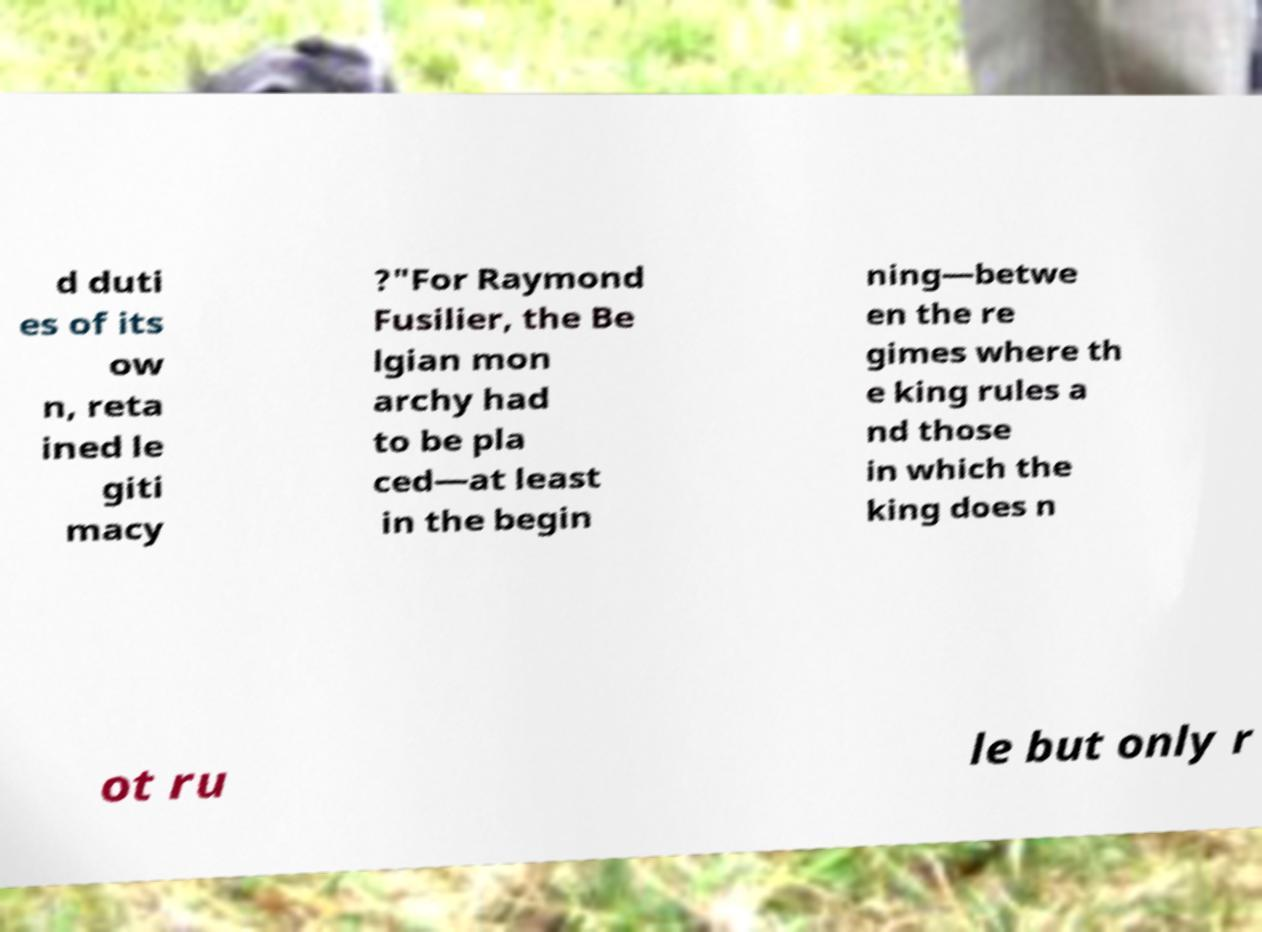For documentation purposes, I need the text within this image transcribed. Could you provide that? d duti es of its ow n, reta ined le giti macy ?"For Raymond Fusilier, the Be lgian mon archy had to be pla ced—at least in the begin ning—betwe en the re gimes where th e king rules a nd those in which the king does n ot ru le but only r 